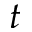<formula> <loc_0><loc_0><loc_500><loc_500>t</formula> 